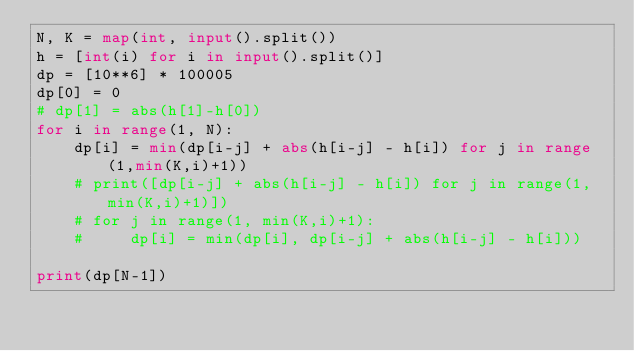<code> <loc_0><loc_0><loc_500><loc_500><_Python_>N, K = map(int, input().split())
h = [int(i) for i in input().split()]
dp = [10**6] * 100005
dp[0] = 0
# dp[1] = abs(h[1]-h[0])
for i in range(1, N):
    dp[i] = min(dp[i-j] + abs(h[i-j] - h[i]) for j in range(1,min(K,i)+1))
    # print([dp[i-j] + abs(h[i-j] - h[i]) for j in range(1,min(K,i)+1)])
    # for j in range(1, min(K,i)+1):
    #     dp[i] = min(dp[i], dp[i-j] + abs(h[i-j] - h[i]))

print(dp[N-1])</code> 